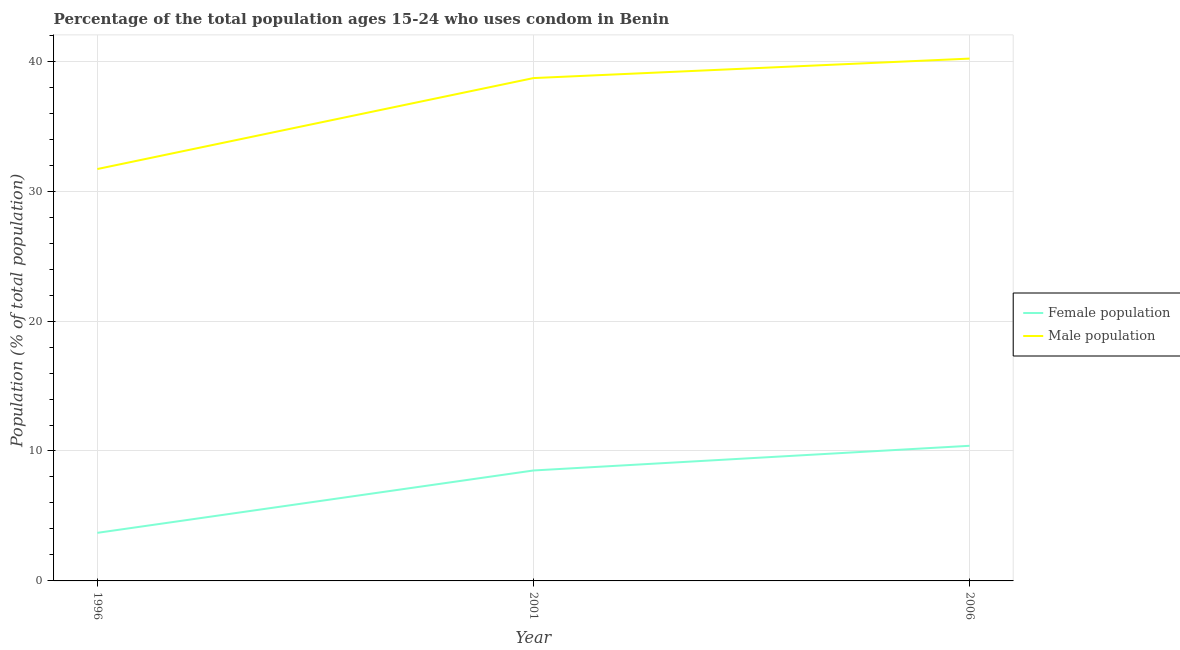How many different coloured lines are there?
Your response must be concise. 2. Is the number of lines equal to the number of legend labels?
Your answer should be compact. Yes. What is the male population in 2006?
Ensure brevity in your answer.  40.2. Across all years, what is the maximum male population?
Your answer should be compact. 40.2. Across all years, what is the minimum male population?
Your answer should be compact. 31.7. In which year was the female population maximum?
Ensure brevity in your answer.  2006. In which year was the male population minimum?
Provide a succinct answer. 1996. What is the total female population in the graph?
Your answer should be very brief. 22.6. What is the difference between the male population in 1996 and that in 2001?
Give a very brief answer. -7. What is the difference between the female population in 2006 and the male population in 2001?
Give a very brief answer. -28.3. What is the average female population per year?
Provide a short and direct response. 7.53. In how many years, is the female population greater than 2 %?
Ensure brevity in your answer.  3. What is the ratio of the female population in 1996 to that in 2001?
Make the answer very short. 0.44. Is the female population in 1996 less than that in 2001?
Your response must be concise. Yes. Is the difference between the male population in 1996 and 2001 greater than the difference between the female population in 1996 and 2001?
Your answer should be compact. No. What is the difference between the highest and the second highest female population?
Your answer should be compact. 1.9. What is the difference between the highest and the lowest male population?
Your response must be concise. 8.5. In how many years, is the male population greater than the average male population taken over all years?
Provide a succinct answer. 2. Is the sum of the male population in 1996 and 2006 greater than the maximum female population across all years?
Provide a short and direct response. Yes. Does the male population monotonically increase over the years?
Ensure brevity in your answer.  Yes. Is the male population strictly greater than the female population over the years?
Give a very brief answer. Yes. How many lines are there?
Your answer should be very brief. 2. How many years are there in the graph?
Provide a succinct answer. 3. What is the difference between two consecutive major ticks on the Y-axis?
Keep it short and to the point. 10. Are the values on the major ticks of Y-axis written in scientific E-notation?
Provide a succinct answer. No. Where does the legend appear in the graph?
Provide a short and direct response. Center right. How many legend labels are there?
Your answer should be very brief. 2. How are the legend labels stacked?
Make the answer very short. Vertical. What is the title of the graph?
Provide a short and direct response. Percentage of the total population ages 15-24 who uses condom in Benin. Does "Non-residents" appear as one of the legend labels in the graph?
Make the answer very short. No. What is the label or title of the Y-axis?
Your answer should be compact. Population (% of total population) . What is the Population (% of total population)  in Male population in 1996?
Offer a terse response. 31.7. What is the Population (% of total population)  in Female population in 2001?
Offer a terse response. 8.5. What is the Population (% of total population)  in Male population in 2001?
Your answer should be compact. 38.7. What is the Population (% of total population)  of Male population in 2006?
Give a very brief answer. 40.2. Across all years, what is the maximum Population (% of total population)  in Female population?
Provide a short and direct response. 10.4. Across all years, what is the maximum Population (% of total population)  in Male population?
Your answer should be compact. 40.2. Across all years, what is the minimum Population (% of total population)  in Male population?
Make the answer very short. 31.7. What is the total Population (% of total population)  of Female population in the graph?
Make the answer very short. 22.6. What is the total Population (% of total population)  in Male population in the graph?
Provide a short and direct response. 110.6. What is the difference between the Population (% of total population)  of Female population in 2001 and that in 2006?
Keep it short and to the point. -1.9. What is the difference between the Population (% of total population)  of Male population in 2001 and that in 2006?
Provide a short and direct response. -1.5. What is the difference between the Population (% of total population)  in Female population in 1996 and the Population (% of total population)  in Male population in 2001?
Provide a succinct answer. -35. What is the difference between the Population (% of total population)  of Female population in 1996 and the Population (% of total population)  of Male population in 2006?
Provide a succinct answer. -36.5. What is the difference between the Population (% of total population)  in Female population in 2001 and the Population (% of total population)  in Male population in 2006?
Your response must be concise. -31.7. What is the average Population (% of total population)  in Female population per year?
Give a very brief answer. 7.53. What is the average Population (% of total population)  in Male population per year?
Ensure brevity in your answer.  36.87. In the year 1996, what is the difference between the Population (% of total population)  of Female population and Population (% of total population)  of Male population?
Offer a very short reply. -28. In the year 2001, what is the difference between the Population (% of total population)  in Female population and Population (% of total population)  in Male population?
Provide a succinct answer. -30.2. In the year 2006, what is the difference between the Population (% of total population)  in Female population and Population (% of total population)  in Male population?
Make the answer very short. -29.8. What is the ratio of the Population (% of total population)  of Female population in 1996 to that in 2001?
Ensure brevity in your answer.  0.44. What is the ratio of the Population (% of total population)  of Male population in 1996 to that in 2001?
Offer a terse response. 0.82. What is the ratio of the Population (% of total population)  in Female population in 1996 to that in 2006?
Offer a very short reply. 0.36. What is the ratio of the Population (% of total population)  in Male population in 1996 to that in 2006?
Keep it short and to the point. 0.79. What is the ratio of the Population (% of total population)  in Female population in 2001 to that in 2006?
Offer a very short reply. 0.82. What is the ratio of the Population (% of total population)  of Male population in 2001 to that in 2006?
Give a very brief answer. 0.96. What is the difference between the highest and the second highest Population (% of total population)  in Male population?
Your answer should be very brief. 1.5. What is the difference between the highest and the lowest Population (% of total population)  in Female population?
Your answer should be compact. 6.7. 